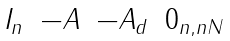Convert formula to latex. <formula><loc_0><loc_0><loc_500><loc_500>\begin{matrix} I _ { n } & - A & - A _ { d } & 0 _ { n , n N } \end{matrix}</formula> 